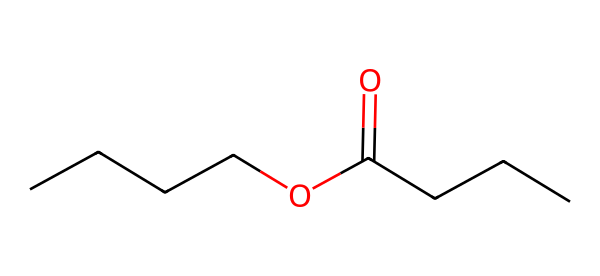What is the molecular formula for butyl butyrate? To determine the molecular formula, we count the number of each type of atom in the structure: there are 7 carbon (C) atoms, 14 hydrogen (H) atoms, and 2 oxygen (O) atoms. Thus, the molecular formula is C7H14O2.
Answer: C7H14O2 How many carbon atoms are in butyl butyrate? By analyzing the SMILES representation, we tally the carbon atoms present. There are 7 carbon atoms in total: 4 from the butyl group and 3 from the butyrate part.
Answer: 7 What functional group is present in butyl butyrate? The presence of the carbonyl (C=O) bonded to an oxygen atom indicates the ester functional group, which is characteristic of esters.
Answer: ester What type of ester is butyl butyrate? Butyl butyrate is a simple ester because it is formed from a straight-chain alcohol (butanol) and a straight-chain carboxylic acid (butyric acid), indicating its categorization as a simple ester.
Answer: simple ester Which part of the structure signifies it being an ester? The ester functional group is characterized by the presence of a carbonyl group (C=O) adjacent to an oxygen atom (O) connected to a carbon chain, which is clearly visible in the chemical structure.
Answer: carbonyl How many double bonds are present in butyl butyrate? By examining the SMILES representation, we note that there is only one double bond, which is found in the carbonyl group (C=O).
Answer: 1 